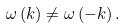Convert formula to latex. <formula><loc_0><loc_0><loc_500><loc_500>\omega \left ( k \right ) \neq \omega \left ( - k \right ) .</formula> 